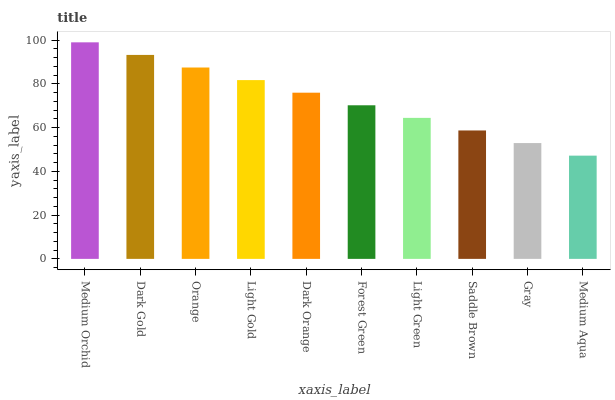Is Medium Aqua the minimum?
Answer yes or no. Yes. Is Medium Orchid the maximum?
Answer yes or no. Yes. Is Dark Gold the minimum?
Answer yes or no. No. Is Dark Gold the maximum?
Answer yes or no. No. Is Medium Orchid greater than Dark Gold?
Answer yes or no. Yes. Is Dark Gold less than Medium Orchid?
Answer yes or no. Yes. Is Dark Gold greater than Medium Orchid?
Answer yes or no. No. Is Medium Orchid less than Dark Gold?
Answer yes or no. No. Is Dark Orange the high median?
Answer yes or no. Yes. Is Forest Green the low median?
Answer yes or no. Yes. Is Forest Green the high median?
Answer yes or no. No. Is Orange the low median?
Answer yes or no. No. 